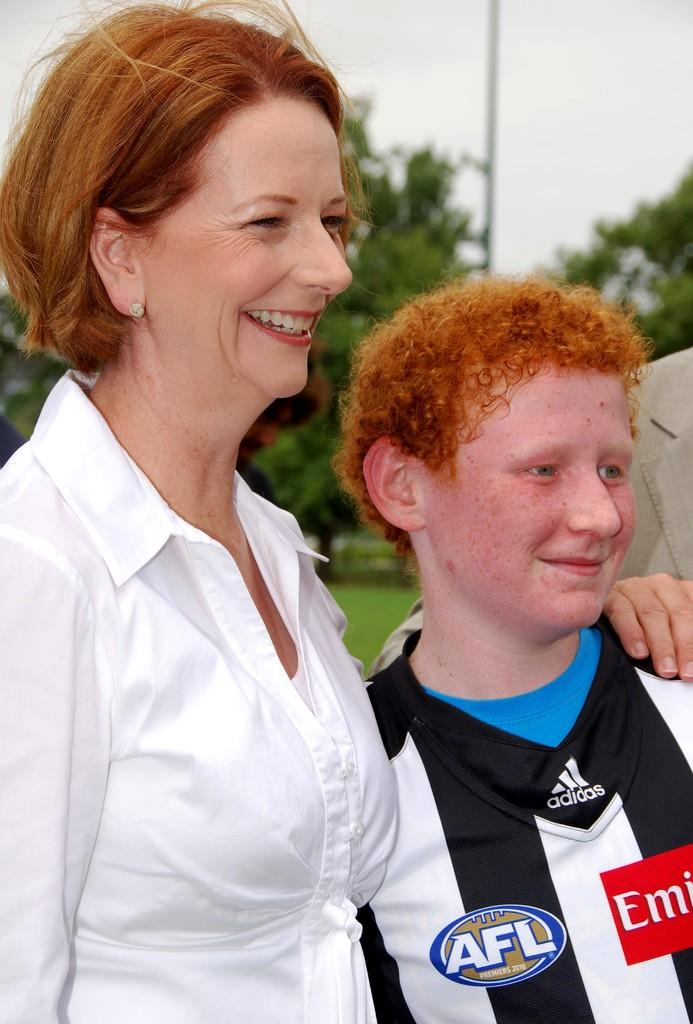<image>
Write a terse but informative summary of the picture. An AFL patch is embroidered on an Adidas shirt that this young man is wearing. 